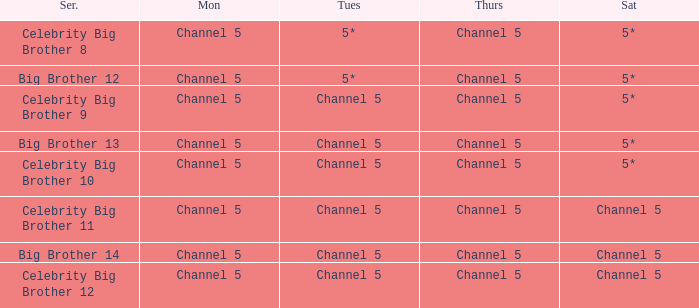Which Thursday does big brother 13 air? Channel 5. 